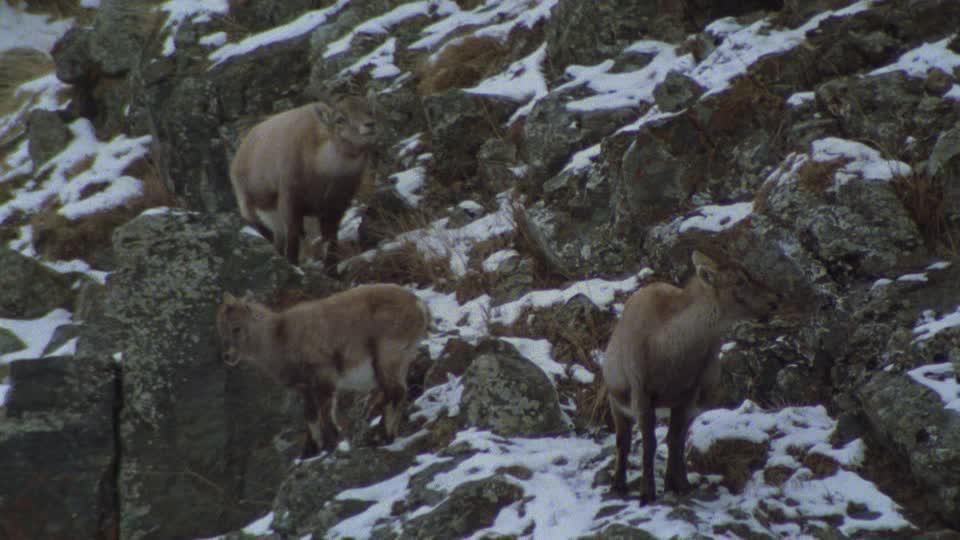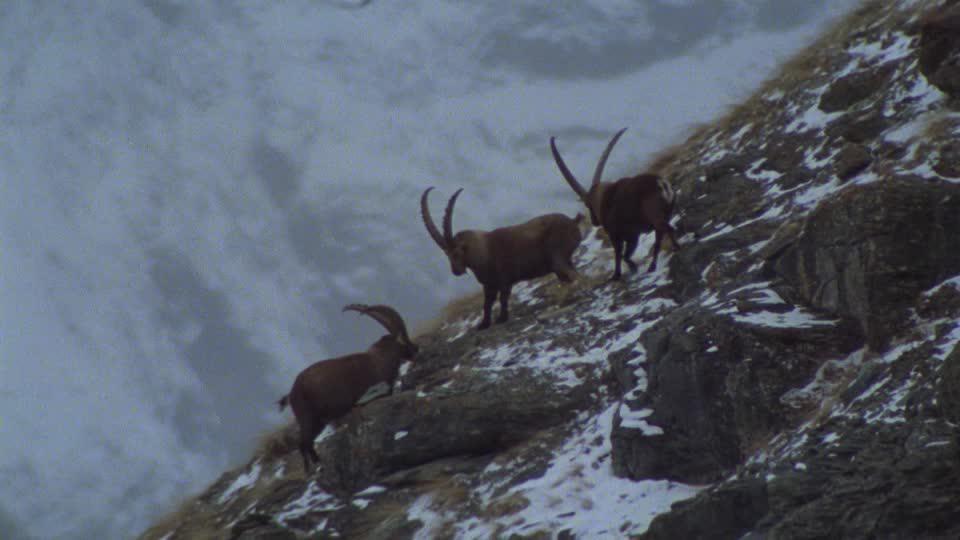The first image is the image on the left, the second image is the image on the right. For the images shown, is this caption "There are six mountain goats." true? Answer yes or no. Yes. 